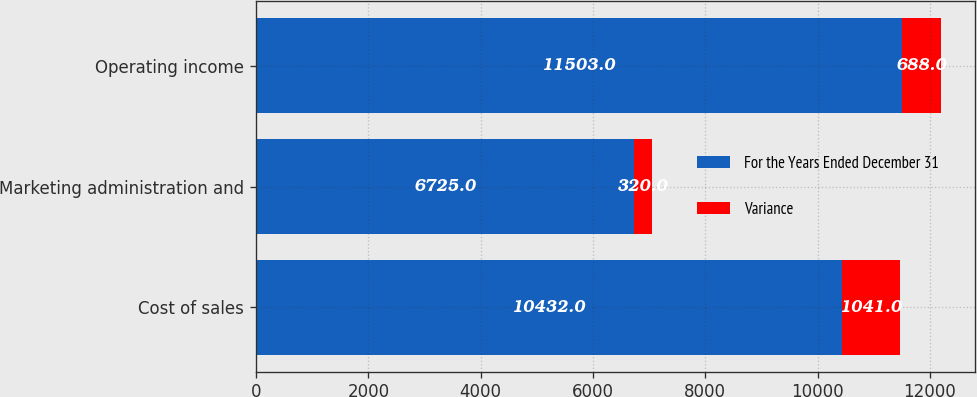Convert chart to OTSL. <chart><loc_0><loc_0><loc_500><loc_500><stacked_bar_chart><ecel><fcel>Cost of sales<fcel>Marketing administration and<fcel>Operating income<nl><fcel>For the Years Ended December 31<fcel>10432<fcel>6725<fcel>11503<nl><fcel>Variance<fcel>1041<fcel>320<fcel>688<nl></chart> 